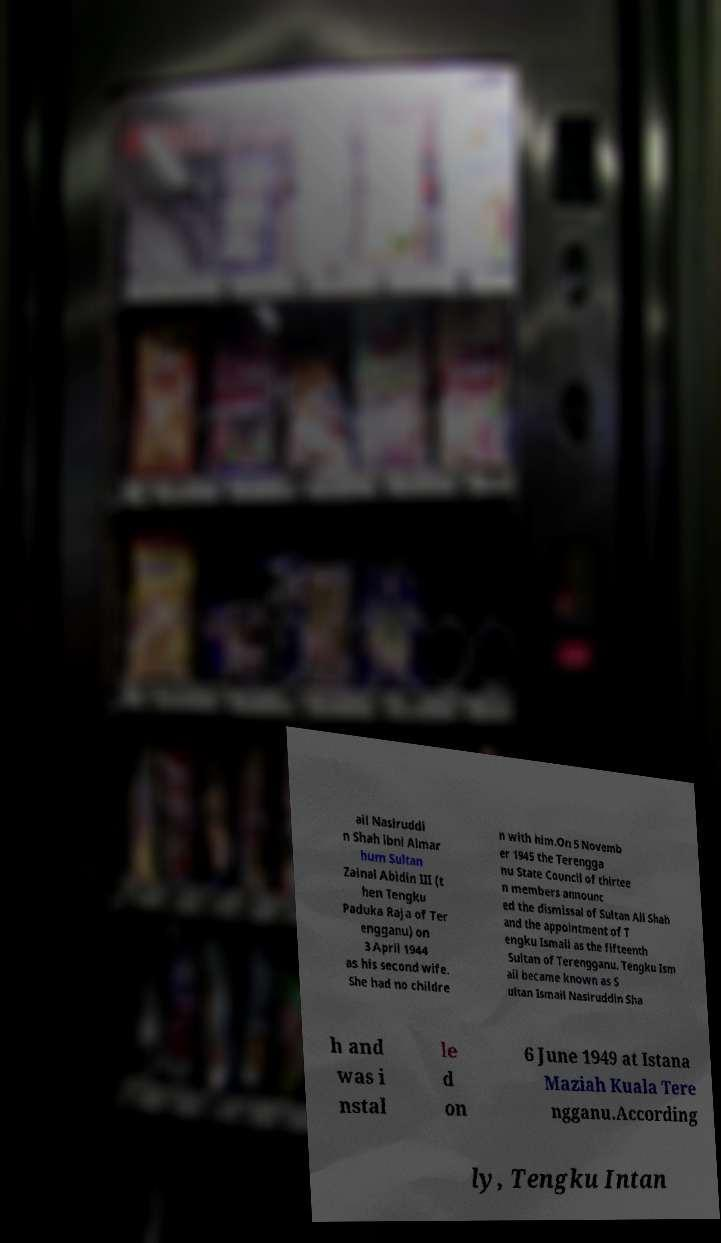There's text embedded in this image that I need extracted. Can you transcribe it verbatim? ail Nasiruddi n Shah ibni Almar hum Sultan Zainal Abidin III (t hen Tengku Paduka Raja of Ter engganu) on 3 April 1944 as his second wife. She had no childre n with him.On 5 Novemb er 1945 the Terengga nu State Council of thirtee n members announc ed the dismissal of Sultan Ali Shah and the appointment of T engku Ismail as the fifteenth Sultan of Terengganu. Tengku Ism ail became known as S ultan Ismail Nasiruddin Sha h and was i nstal le d on 6 June 1949 at Istana Maziah Kuala Tere ngganu.According ly, Tengku Intan 